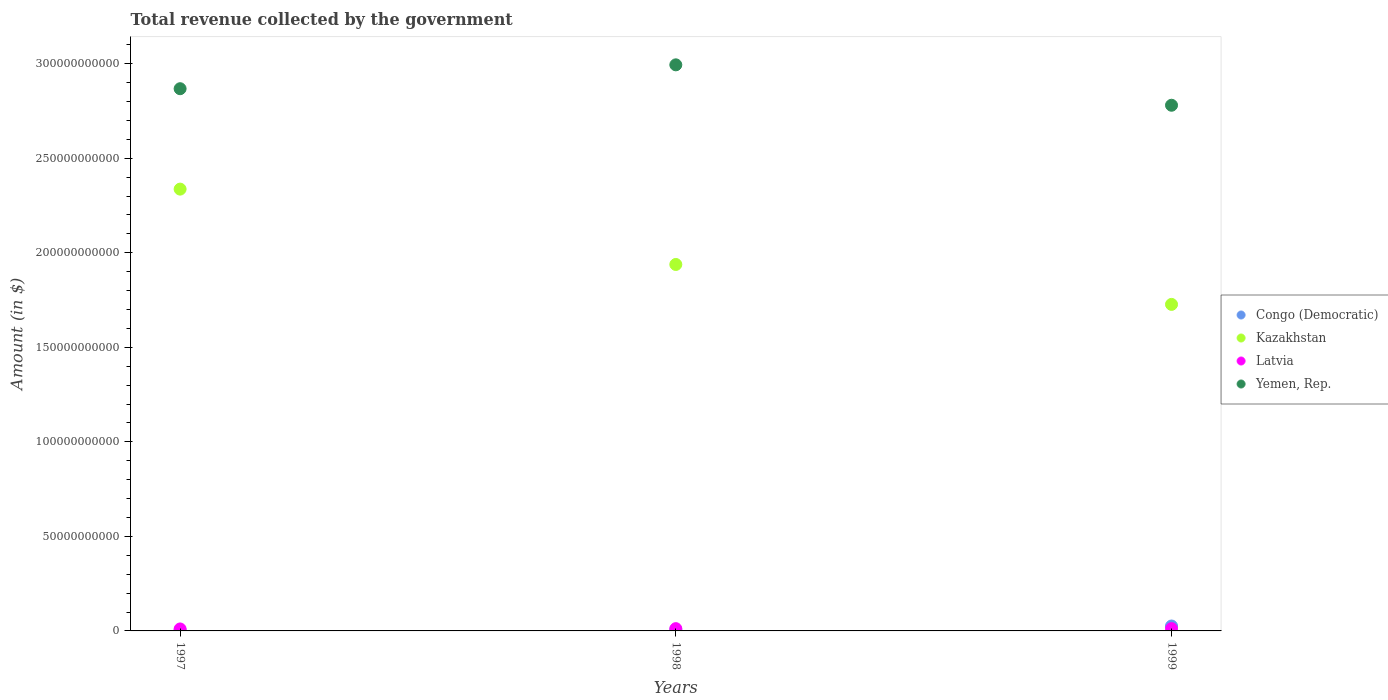What is the total revenue collected by the government in Yemen, Rep. in 1997?
Offer a very short reply. 2.87e+11. Across all years, what is the maximum total revenue collected by the government in Kazakhstan?
Give a very brief answer. 2.34e+11. Across all years, what is the minimum total revenue collected by the government in Yemen, Rep.?
Your response must be concise. 2.78e+11. What is the total total revenue collected by the government in Yemen, Rep. in the graph?
Offer a very short reply. 8.64e+11. What is the difference between the total revenue collected by the government in Congo (Democratic) in 1997 and that in 1998?
Your response must be concise. -2.01e+08. What is the difference between the total revenue collected by the government in Latvia in 1998 and the total revenue collected by the government in Yemen, Rep. in 1997?
Provide a short and direct response. -2.86e+11. What is the average total revenue collected by the government in Kazakhstan per year?
Provide a short and direct response. 2.00e+11. In the year 1997, what is the difference between the total revenue collected by the government in Latvia and total revenue collected by the government in Kazakhstan?
Offer a terse response. -2.33e+11. In how many years, is the total revenue collected by the government in Congo (Democratic) greater than 300000000000 $?
Your answer should be very brief. 0. What is the ratio of the total revenue collected by the government in Kazakhstan in 1997 to that in 1999?
Your response must be concise. 1.35. What is the difference between the highest and the second highest total revenue collected by the government in Congo (Democratic)?
Your response must be concise. 1.99e+09. What is the difference between the highest and the lowest total revenue collected by the government in Yemen, Rep.?
Your response must be concise. 2.14e+1. Is it the case that in every year, the sum of the total revenue collected by the government in Latvia and total revenue collected by the government in Congo (Democratic)  is greater than the sum of total revenue collected by the government in Yemen, Rep. and total revenue collected by the government in Kazakhstan?
Offer a very short reply. No. Is the total revenue collected by the government in Yemen, Rep. strictly greater than the total revenue collected by the government in Kazakhstan over the years?
Offer a terse response. Yes. Is the total revenue collected by the government in Kazakhstan strictly less than the total revenue collected by the government in Latvia over the years?
Provide a short and direct response. No. How many years are there in the graph?
Ensure brevity in your answer.  3. Are the values on the major ticks of Y-axis written in scientific E-notation?
Make the answer very short. No. Does the graph contain any zero values?
Provide a succinct answer. No. Does the graph contain grids?
Offer a very short reply. No. How are the legend labels stacked?
Provide a succinct answer. Vertical. What is the title of the graph?
Provide a short and direct response. Total revenue collected by the government. Does "High income: nonOECD" appear as one of the legend labels in the graph?
Offer a terse response. No. What is the label or title of the X-axis?
Give a very brief answer. Years. What is the label or title of the Y-axis?
Keep it short and to the point. Amount (in $). What is the Amount (in $) of Congo (Democratic) in 1997?
Offer a very short reply. 4.04e+08. What is the Amount (in $) of Kazakhstan in 1997?
Offer a very short reply. 2.34e+11. What is the Amount (in $) of Latvia in 1997?
Make the answer very short. 1.04e+09. What is the Amount (in $) of Yemen, Rep. in 1997?
Your response must be concise. 2.87e+11. What is the Amount (in $) in Congo (Democratic) in 1998?
Your answer should be compact. 6.04e+08. What is the Amount (in $) of Kazakhstan in 1998?
Your response must be concise. 1.94e+11. What is the Amount (in $) in Latvia in 1998?
Keep it short and to the point. 1.20e+09. What is the Amount (in $) in Yemen, Rep. in 1998?
Your response must be concise. 2.99e+11. What is the Amount (in $) in Congo (Democratic) in 1999?
Your answer should be very brief. 2.60e+09. What is the Amount (in $) in Kazakhstan in 1999?
Your answer should be very brief. 1.73e+11. What is the Amount (in $) of Latvia in 1999?
Keep it short and to the point. 1.22e+09. What is the Amount (in $) of Yemen, Rep. in 1999?
Offer a very short reply. 2.78e+11. Across all years, what is the maximum Amount (in $) in Congo (Democratic)?
Your answer should be very brief. 2.60e+09. Across all years, what is the maximum Amount (in $) of Kazakhstan?
Ensure brevity in your answer.  2.34e+11. Across all years, what is the maximum Amount (in $) in Latvia?
Your response must be concise. 1.22e+09. Across all years, what is the maximum Amount (in $) of Yemen, Rep.?
Your response must be concise. 2.99e+11. Across all years, what is the minimum Amount (in $) of Congo (Democratic)?
Offer a very short reply. 4.04e+08. Across all years, what is the minimum Amount (in $) of Kazakhstan?
Your answer should be compact. 1.73e+11. Across all years, what is the minimum Amount (in $) of Latvia?
Ensure brevity in your answer.  1.04e+09. Across all years, what is the minimum Amount (in $) of Yemen, Rep.?
Offer a very short reply. 2.78e+11. What is the total Amount (in $) of Congo (Democratic) in the graph?
Ensure brevity in your answer.  3.60e+09. What is the total Amount (in $) of Kazakhstan in the graph?
Your answer should be very brief. 6.00e+11. What is the total Amount (in $) of Latvia in the graph?
Provide a succinct answer. 3.47e+09. What is the total Amount (in $) in Yemen, Rep. in the graph?
Your response must be concise. 8.64e+11. What is the difference between the Amount (in $) in Congo (Democratic) in 1997 and that in 1998?
Provide a succinct answer. -2.01e+08. What is the difference between the Amount (in $) in Kazakhstan in 1997 and that in 1998?
Offer a very short reply. 3.99e+1. What is the difference between the Amount (in $) in Latvia in 1997 and that in 1998?
Keep it short and to the point. -1.60e+08. What is the difference between the Amount (in $) of Yemen, Rep. in 1997 and that in 1998?
Provide a succinct answer. -1.26e+1. What is the difference between the Amount (in $) of Congo (Democratic) in 1997 and that in 1999?
Keep it short and to the point. -2.19e+09. What is the difference between the Amount (in $) in Kazakhstan in 1997 and that in 1999?
Provide a short and direct response. 6.10e+1. What is the difference between the Amount (in $) in Latvia in 1997 and that in 1999?
Provide a short and direct response. -1.79e+08. What is the difference between the Amount (in $) of Yemen, Rep. in 1997 and that in 1999?
Your response must be concise. 8.75e+09. What is the difference between the Amount (in $) of Congo (Democratic) in 1998 and that in 1999?
Ensure brevity in your answer.  -1.99e+09. What is the difference between the Amount (in $) in Kazakhstan in 1998 and that in 1999?
Your answer should be very brief. 2.11e+1. What is the difference between the Amount (in $) in Latvia in 1998 and that in 1999?
Provide a short and direct response. -1.83e+07. What is the difference between the Amount (in $) in Yemen, Rep. in 1998 and that in 1999?
Offer a very short reply. 2.14e+1. What is the difference between the Amount (in $) of Congo (Democratic) in 1997 and the Amount (in $) of Kazakhstan in 1998?
Give a very brief answer. -1.93e+11. What is the difference between the Amount (in $) of Congo (Democratic) in 1997 and the Amount (in $) of Latvia in 1998?
Make the answer very short. -7.99e+08. What is the difference between the Amount (in $) in Congo (Democratic) in 1997 and the Amount (in $) in Yemen, Rep. in 1998?
Offer a very short reply. -2.99e+11. What is the difference between the Amount (in $) of Kazakhstan in 1997 and the Amount (in $) of Latvia in 1998?
Your answer should be compact. 2.32e+11. What is the difference between the Amount (in $) in Kazakhstan in 1997 and the Amount (in $) in Yemen, Rep. in 1998?
Keep it short and to the point. -6.57e+1. What is the difference between the Amount (in $) in Latvia in 1997 and the Amount (in $) in Yemen, Rep. in 1998?
Make the answer very short. -2.98e+11. What is the difference between the Amount (in $) in Congo (Democratic) in 1997 and the Amount (in $) in Kazakhstan in 1999?
Your response must be concise. -1.72e+11. What is the difference between the Amount (in $) of Congo (Democratic) in 1997 and the Amount (in $) of Latvia in 1999?
Provide a succinct answer. -8.17e+08. What is the difference between the Amount (in $) in Congo (Democratic) in 1997 and the Amount (in $) in Yemen, Rep. in 1999?
Offer a very short reply. -2.78e+11. What is the difference between the Amount (in $) in Kazakhstan in 1997 and the Amount (in $) in Latvia in 1999?
Make the answer very short. 2.32e+11. What is the difference between the Amount (in $) in Kazakhstan in 1997 and the Amount (in $) in Yemen, Rep. in 1999?
Offer a terse response. -4.44e+1. What is the difference between the Amount (in $) of Latvia in 1997 and the Amount (in $) of Yemen, Rep. in 1999?
Give a very brief answer. -2.77e+11. What is the difference between the Amount (in $) of Congo (Democratic) in 1998 and the Amount (in $) of Kazakhstan in 1999?
Offer a very short reply. -1.72e+11. What is the difference between the Amount (in $) in Congo (Democratic) in 1998 and the Amount (in $) in Latvia in 1999?
Your response must be concise. -6.16e+08. What is the difference between the Amount (in $) of Congo (Democratic) in 1998 and the Amount (in $) of Yemen, Rep. in 1999?
Offer a very short reply. -2.77e+11. What is the difference between the Amount (in $) in Kazakhstan in 1998 and the Amount (in $) in Latvia in 1999?
Give a very brief answer. 1.93e+11. What is the difference between the Amount (in $) of Kazakhstan in 1998 and the Amount (in $) of Yemen, Rep. in 1999?
Offer a terse response. -8.42e+1. What is the difference between the Amount (in $) of Latvia in 1998 and the Amount (in $) of Yemen, Rep. in 1999?
Ensure brevity in your answer.  -2.77e+11. What is the average Amount (in $) of Congo (Democratic) per year?
Offer a very short reply. 1.20e+09. What is the average Amount (in $) of Kazakhstan per year?
Make the answer very short. 2.00e+11. What is the average Amount (in $) of Latvia per year?
Give a very brief answer. 1.16e+09. What is the average Amount (in $) in Yemen, Rep. per year?
Ensure brevity in your answer.  2.88e+11. In the year 1997, what is the difference between the Amount (in $) of Congo (Democratic) and Amount (in $) of Kazakhstan?
Provide a succinct answer. -2.33e+11. In the year 1997, what is the difference between the Amount (in $) in Congo (Democratic) and Amount (in $) in Latvia?
Provide a succinct answer. -6.38e+08. In the year 1997, what is the difference between the Amount (in $) of Congo (Democratic) and Amount (in $) of Yemen, Rep.?
Keep it short and to the point. -2.86e+11. In the year 1997, what is the difference between the Amount (in $) of Kazakhstan and Amount (in $) of Latvia?
Your answer should be very brief. 2.33e+11. In the year 1997, what is the difference between the Amount (in $) in Kazakhstan and Amount (in $) in Yemen, Rep.?
Ensure brevity in your answer.  -5.31e+1. In the year 1997, what is the difference between the Amount (in $) in Latvia and Amount (in $) in Yemen, Rep.?
Ensure brevity in your answer.  -2.86e+11. In the year 1998, what is the difference between the Amount (in $) in Congo (Democratic) and Amount (in $) in Kazakhstan?
Keep it short and to the point. -1.93e+11. In the year 1998, what is the difference between the Amount (in $) of Congo (Democratic) and Amount (in $) of Latvia?
Offer a terse response. -5.98e+08. In the year 1998, what is the difference between the Amount (in $) of Congo (Democratic) and Amount (in $) of Yemen, Rep.?
Make the answer very short. -2.99e+11. In the year 1998, what is the difference between the Amount (in $) in Kazakhstan and Amount (in $) in Latvia?
Keep it short and to the point. 1.93e+11. In the year 1998, what is the difference between the Amount (in $) in Kazakhstan and Amount (in $) in Yemen, Rep.?
Your response must be concise. -1.06e+11. In the year 1998, what is the difference between the Amount (in $) of Latvia and Amount (in $) of Yemen, Rep.?
Make the answer very short. -2.98e+11. In the year 1999, what is the difference between the Amount (in $) of Congo (Democratic) and Amount (in $) of Kazakhstan?
Make the answer very short. -1.70e+11. In the year 1999, what is the difference between the Amount (in $) of Congo (Democratic) and Amount (in $) of Latvia?
Your answer should be compact. 1.38e+09. In the year 1999, what is the difference between the Amount (in $) in Congo (Democratic) and Amount (in $) in Yemen, Rep.?
Ensure brevity in your answer.  -2.75e+11. In the year 1999, what is the difference between the Amount (in $) of Kazakhstan and Amount (in $) of Latvia?
Make the answer very short. 1.71e+11. In the year 1999, what is the difference between the Amount (in $) of Kazakhstan and Amount (in $) of Yemen, Rep.?
Make the answer very short. -1.05e+11. In the year 1999, what is the difference between the Amount (in $) of Latvia and Amount (in $) of Yemen, Rep.?
Offer a terse response. -2.77e+11. What is the ratio of the Amount (in $) in Congo (Democratic) in 1997 to that in 1998?
Your answer should be compact. 0.67. What is the ratio of the Amount (in $) in Kazakhstan in 1997 to that in 1998?
Provide a succinct answer. 1.21. What is the ratio of the Amount (in $) of Latvia in 1997 to that in 1998?
Give a very brief answer. 0.87. What is the ratio of the Amount (in $) in Yemen, Rep. in 1997 to that in 1998?
Provide a short and direct response. 0.96. What is the ratio of the Amount (in $) of Congo (Democratic) in 1997 to that in 1999?
Provide a succinct answer. 0.16. What is the ratio of the Amount (in $) of Kazakhstan in 1997 to that in 1999?
Give a very brief answer. 1.35. What is the ratio of the Amount (in $) in Latvia in 1997 to that in 1999?
Make the answer very short. 0.85. What is the ratio of the Amount (in $) in Yemen, Rep. in 1997 to that in 1999?
Keep it short and to the point. 1.03. What is the ratio of the Amount (in $) in Congo (Democratic) in 1998 to that in 1999?
Your answer should be very brief. 0.23. What is the ratio of the Amount (in $) in Kazakhstan in 1998 to that in 1999?
Your answer should be compact. 1.12. What is the ratio of the Amount (in $) in Yemen, Rep. in 1998 to that in 1999?
Your answer should be very brief. 1.08. What is the difference between the highest and the second highest Amount (in $) of Congo (Democratic)?
Ensure brevity in your answer.  1.99e+09. What is the difference between the highest and the second highest Amount (in $) in Kazakhstan?
Offer a very short reply. 3.99e+1. What is the difference between the highest and the second highest Amount (in $) in Latvia?
Provide a short and direct response. 1.83e+07. What is the difference between the highest and the second highest Amount (in $) of Yemen, Rep.?
Your answer should be very brief. 1.26e+1. What is the difference between the highest and the lowest Amount (in $) in Congo (Democratic)?
Your answer should be compact. 2.19e+09. What is the difference between the highest and the lowest Amount (in $) of Kazakhstan?
Ensure brevity in your answer.  6.10e+1. What is the difference between the highest and the lowest Amount (in $) in Latvia?
Ensure brevity in your answer.  1.79e+08. What is the difference between the highest and the lowest Amount (in $) of Yemen, Rep.?
Give a very brief answer. 2.14e+1. 